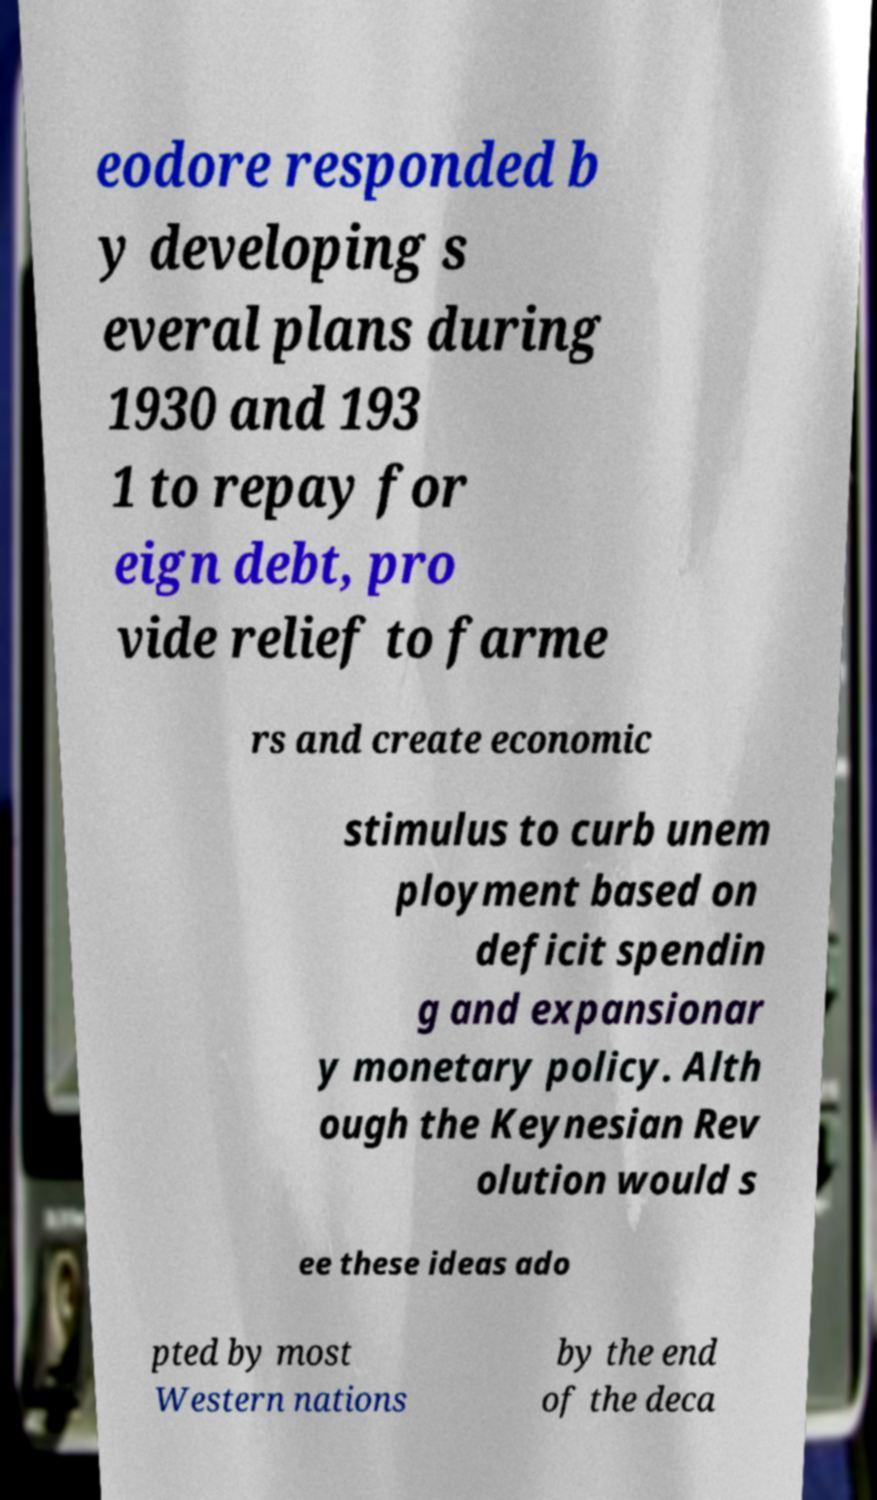Please identify and transcribe the text found in this image. eodore responded b y developing s everal plans during 1930 and 193 1 to repay for eign debt, pro vide relief to farme rs and create economic stimulus to curb unem ployment based on deficit spendin g and expansionar y monetary policy. Alth ough the Keynesian Rev olution would s ee these ideas ado pted by most Western nations by the end of the deca 